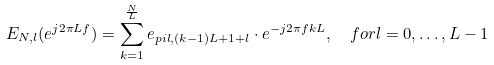<formula> <loc_0><loc_0><loc_500><loc_500>E _ { N , l } ( e ^ { j 2 \pi L f } ) & = \sum _ { k = 1 } ^ { \frac { N } { L } } e _ { p i l , ( k - 1 ) L + 1 + l } \cdot e ^ { - j 2 \pi f k L } , \quad f o r l = 0 , \hdots , L - 1</formula> 